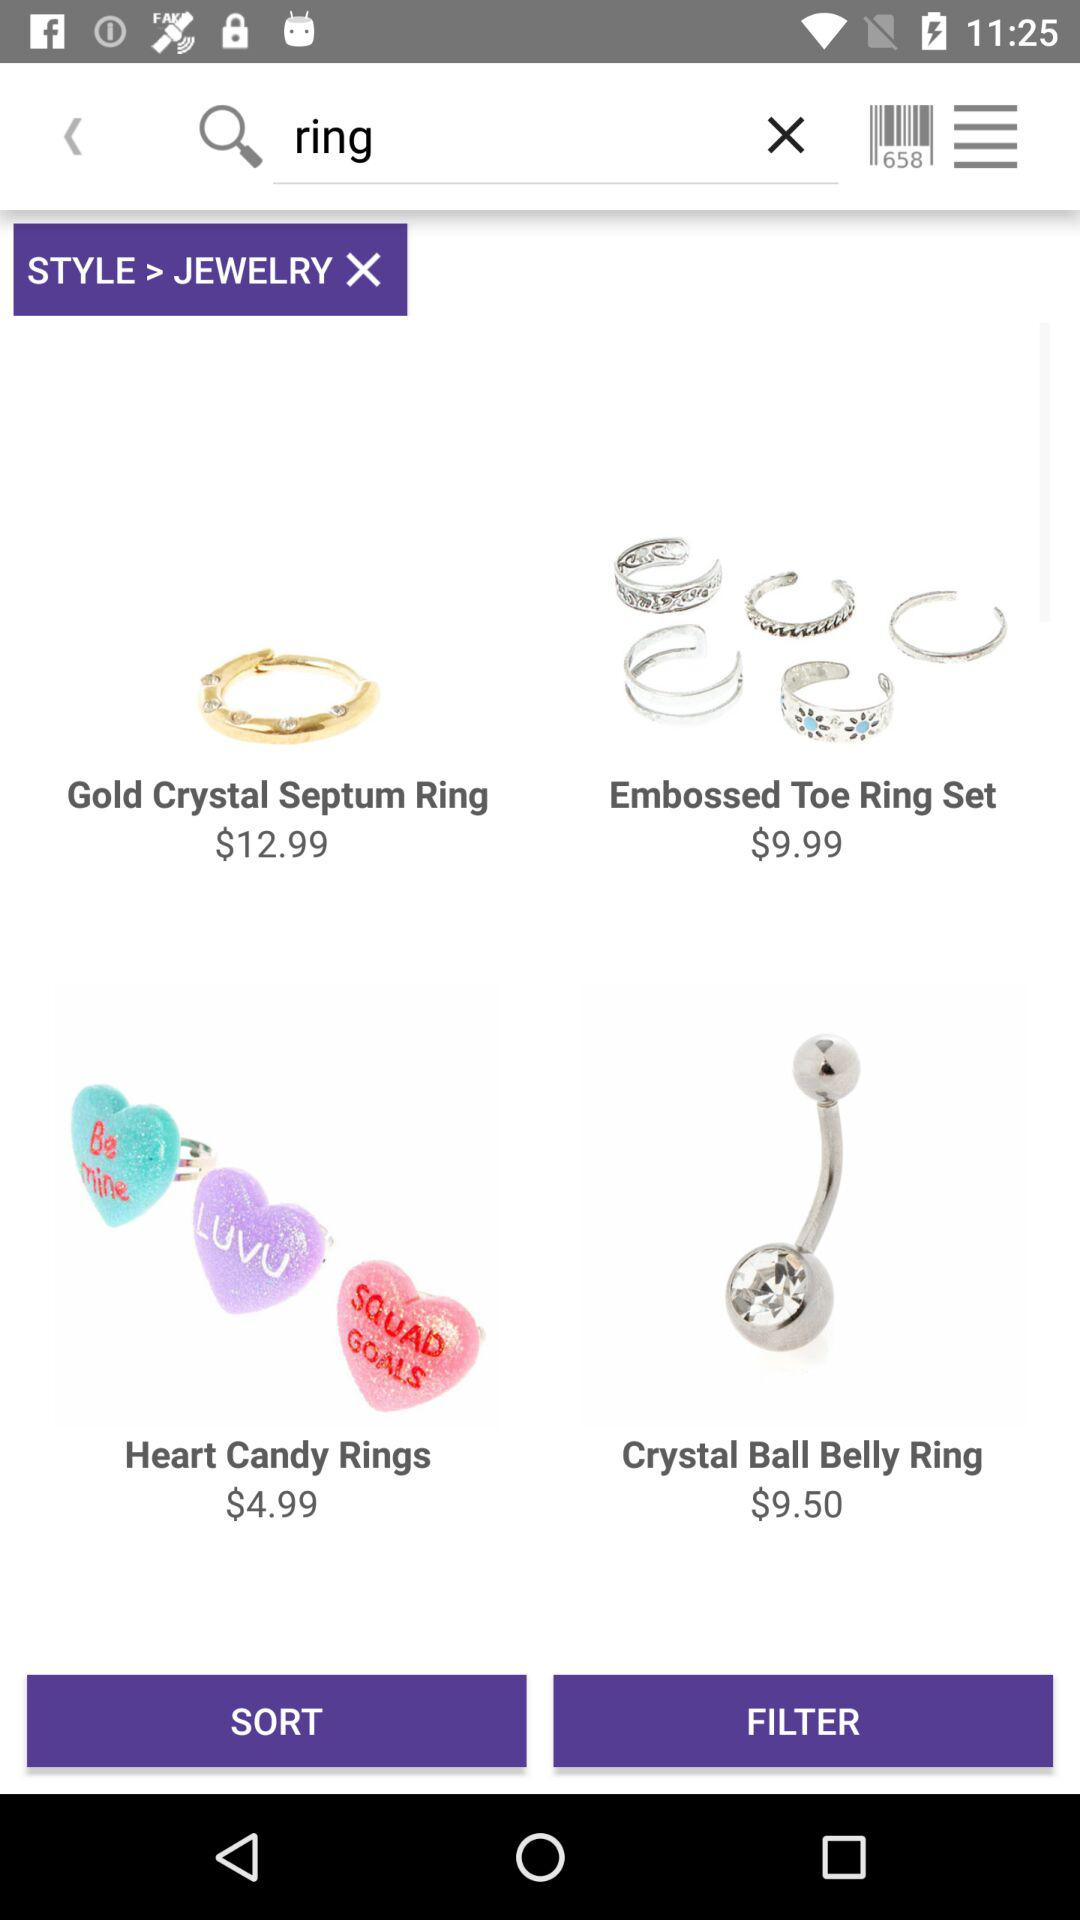How much more expensive is the gold crystal septum ring than the heart candy rings?
Answer the question using a single word or phrase. $8.00 